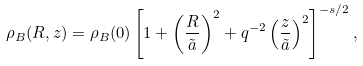<formula> <loc_0><loc_0><loc_500><loc_500>\rho _ { B } ( R , z ) = \rho _ { B } ( 0 ) \left [ 1 + \left ( \frac { R } { \tilde { a } } \right ) ^ { 2 } + q ^ { - 2 } \left ( \frac { z } { \tilde { a } } \right ) ^ { 2 } \right ] ^ { - s / 2 } ,</formula> 